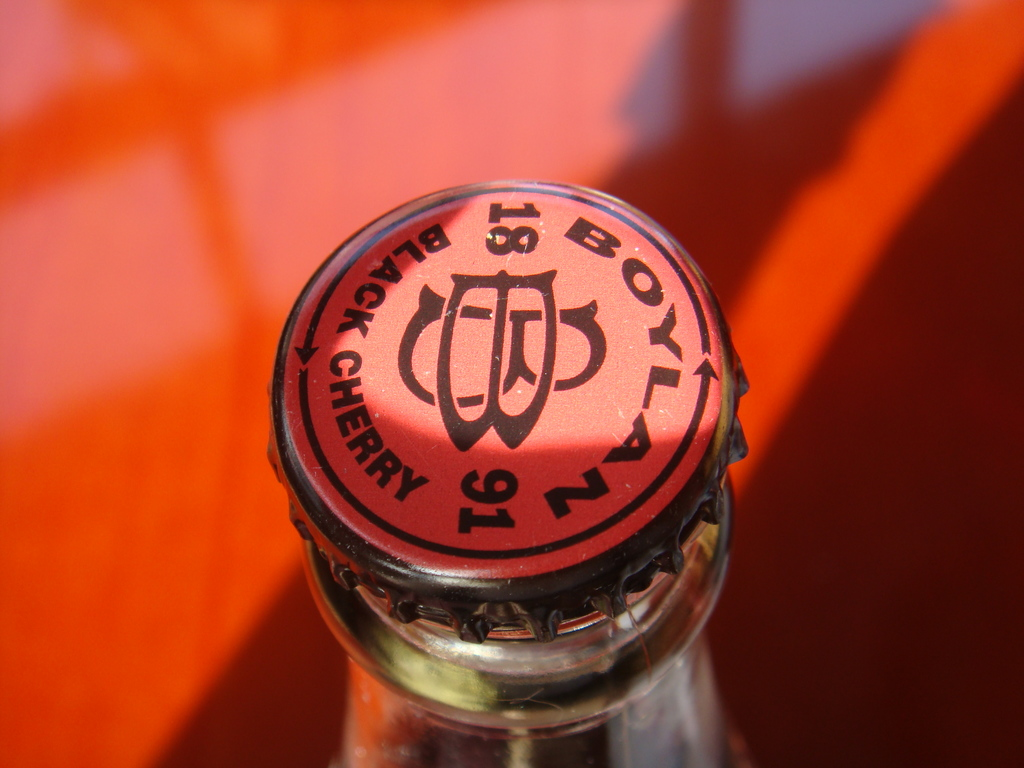Can you describe the main features of this image for me? The image presents a vibrant and detailed close-up of a red bottle cap, stamped with the text 'BOWL 91' and 'CHERRY' in a contrasting black font. This cap seals a glass bottle, as indicated by the visible neck of the bottle beneath the cap. The background exudes a fiery orange hue, suggesting a sunny, warm setting that enhances the red's vibrancy. The bottle likely contains a cherry-flavored beverage, possibly from a special or limited series indicated by 'BOWL 91', suggesting a unique or seasonal product offering. 